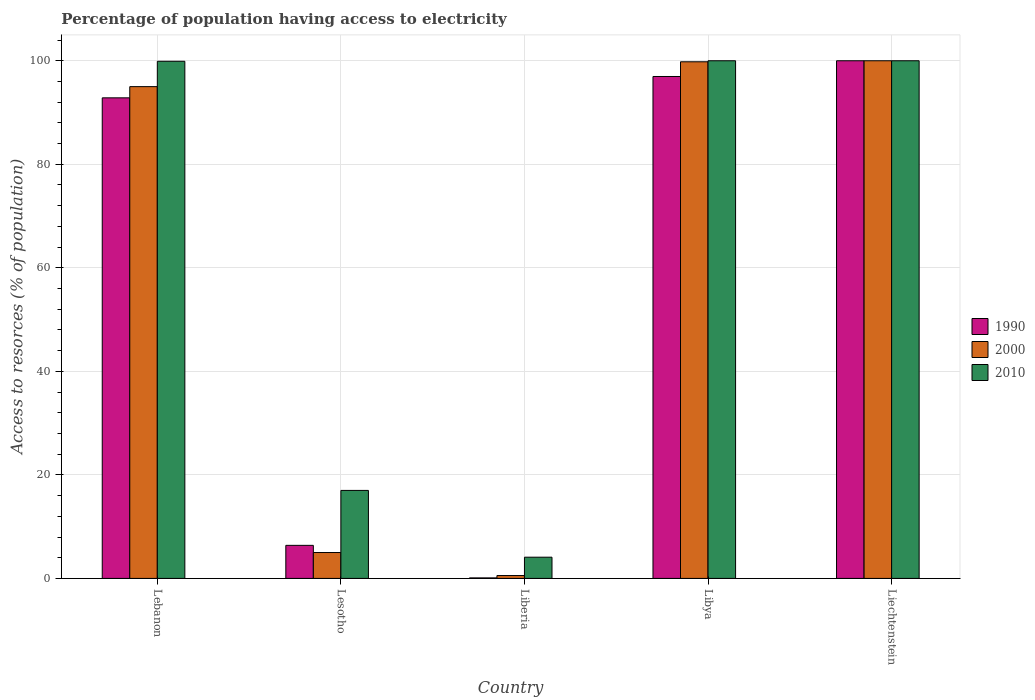How many different coloured bars are there?
Offer a terse response. 3. Are the number of bars per tick equal to the number of legend labels?
Keep it short and to the point. Yes. Are the number of bars on each tick of the X-axis equal?
Offer a terse response. Yes. How many bars are there on the 5th tick from the left?
Your answer should be compact. 3. What is the label of the 1st group of bars from the left?
Keep it short and to the point. Lebanon. In how many cases, is the number of bars for a given country not equal to the number of legend labels?
Ensure brevity in your answer.  0. What is the percentage of population having access to electricity in 2000 in Lesotho?
Ensure brevity in your answer.  5. Across all countries, what is the maximum percentage of population having access to electricity in 2010?
Offer a very short reply. 100. Across all countries, what is the minimum percentage of population having access to electricity in 1990?
Provide a short and direct response. 0.1. In which country was the percentage of population having access to electricity in 2000 maximum?
Offer a terse response. Liechtenstein. In which country was the percentage of population having access to electricity in 1990 minimum?
Provide a succinct answer. Liberia. What is the total percentage of population having access to electricity in 2000 in the graph?
Give a very brief answer. 300.36. What is the difference between the percentage of population having access to electricity in 1990 in Liberia and that in Libya?
Make the answer very short. -96.86. What is the difference between the percentage of population having access to electricity in 1990 in Libya and the percentage of population having access to electricity in 2000 in Lesotho?
Offer a very short reply. 91.96. What is the average percentage of population having access to electricity in 1990 per country?
Your answer should be compact. 59.26. What is the difference between the percentage of population having access to electricity of/in 1990 and percentage of population having access to electricity of/in 2010 in Libya?
Offer a very short reply. -3.04. In how many countries, is the percentage of population having access to electricity in 2010 greater than 88 %?
Your response must be concise. 3. Is the percentage of population having access to electricity in 1990 in Lebanon less than that in Liberia?
Your answer should be compact. No. What is the difference between the highest and the second highest percentage of population having access to electricity in 1990?
Make the answer very short. -3.04. What is the difference between the highest and the lowest percentage of population having access to electricity in 1990?
Keep it short and to the point. 99.9. Is the sum of the percentage of population having access to electricity in 2000 in Lesotho and Libya greater than the maximum percentage of population having access to electricity in 2010 across all countries?
Make the answer very short. Yes. What does the 3rd bar from the right in Lebanon represents?
Ensure brevity in your answer.  1990. Is it the case that in every country, the sum of the percentage of population having access to electricity in 2010 and percentage of population having access to electricity in 2000 is greater than the percentage of population having access to electricity in 1990?
Ensure brevity in your answer.  Yes. How many bars are there?
Provide a succinct answer. 15. Are all the bars in the graph horizontal?
Provide a short and direct response. No. What is the difference between two consecutive major ticks on the Y-axis?
Your response must be concise. 20. Does the graph contain any zero values?
Offer a very short reply. No. How many legend labels are there?
Ensure brevity in your answer.  3. How are the legend labels stacked?
Provide a succinct answer. Vertical. What is the title of the graph?
Offer a very short reply. Percentage of population having access to electricity. What is the label or title of the X-axis?
Keep it short and to the point. Country. What is the label or title of the Y-axis?
Give a very brief answer. Access to resorces (% of population). What is the Access to resorces (% of population) of 1990 in Lebanon?
Ensure brevity in your answer.  92.84. What is the Access to resorces (% of population) of 2010 in Lebanon?
Provide a short and direct response. 99.9. What is the Access to resorces (% of population) in 1990 in Lesotho?
Keep it short and to the point. 6.39. What is the Access to resorces (% of population) of 2000 in Lesotho?
Offer a terse response. 5. What is the Access to resorces (% of population) of 2010 in Lesotho?
Offer a terse response. 17. What is the Access to resorces (% of population) in 1990 in Liberia?
Give a very brief answer. 0.1. What is the Access to resorces (% of population) of 2000 in Liberia?
Provide a short and direct response. 0.56. What is the Access to resorces (% of population) in 1990 in Libya?
Your answer should be compact. 96.96. What is the Access to resorces (% of population) in 2000 in Libya?
Ensure brevity in your answer.  99.8. What is the Access to resorces (% of population) in 2010 in Libya?
Provide a short and direct response. 100. What is the Access to resorces (% of population) of 1990 in Liechtenstein?
Make the answer very short. 100. Across all countries, what is the maximum Access to resorces (% of population) of 2010?
Your answer should be very brief. 100. Across all countries, what is the minimum Access to resorces (% of population) in 1990?
Give a very brief answer. 0.1. Across all countries, what is the minimum Access to resorces (% of population) in 2000?
Provide a succinct answer. 0.56. Across all countries, what is the minimum Access to resorces (% of population) of 2010?
Provide a short and direct response. 4.1. What is the total Access to resorces (% of population) of 1990 in the graph?
Make the answer very short. 296.29. What is the total Access to resorces (% of population) in 2000 in the graph?
Ensure brevity in your answer.  300.36. What is the total Access to resorces (% of population) in 2010 in the graph?
Give a very brief answer. 321. What is the difference between the Access to resorces (% of population) in 1990 in Lebanon and that in Lesotho?
Offer a very short reply. 86.45. What is the difference between the Access to resorces (% of population) of 2010 in Lebanon and that in Lesotho?
Offer a very short reply. 82.9. What is the difference between the Access to resorces (% of population) in 1990 in Lebanon and that in Liberia?
Ensure brevity in your answer.  92.74. What is the difference between the Access to resorces (% of population) in 2000 in Lebanon and that in Liberia?
Your answer should be very brief. 94.44. What is the difference between the Access to resorces (% of population) of 2010 in Lebanon and that in Liberia?
Provide a short and direct response. 95.8. What is the difference between the Access to resorces (% of population) of 1990 in Lebanon and that in Libya?
Make the answer very short. -4.12. What is the difference between the Access to resorces (% of population) of 2000 in Lebanon and that in Libya?
Offer a very short reply. -4.8. What is the difference between the Access to resorces (% of population) in 2010 in Lebanon and that in Libya?
Your response must be concise. -0.1. What is the difference between the Access to resorces (% of population) in 1990 in Lebanon and that in Liechtenstein?
Ensure brevity in your answer.  -7.16. What is the difference between the Access to resorces (% of population) in 1990 in Lesotho and that in Liberia?
Provide a succinct answer. 6.29. What is the difference between the Access to resorces (% of population) of 2000 in Lesotho and that in Liberia?
Give a very brief answer. 4.44. What is the difference between the Access to resorces (% of population) in 2010 in Lesotho and that in Liberia?
Your response must be concise. 12.9. What is the difference between the Access to resorces (% of population) of 1990 in Lesotho and that in Libya?
Your response must be concise. -90.57. What is the difference between the Access to resorces (% of population) in 2000 in Lesotho and that in Libya?
Offer a very short reply. -94.8. What is the difference between the Access to resorces (% of population) in 2010 in Lesotho and that in Libya?
Keep it short and to the point. -83. What is the difference between the Access to resorces (% of population) of 1990 in Lesotho and that in Liechtenstein?
Give a very brief answer. -93.61. What is the difference between the Access to resorces (% of population) of 2000 in Lesotho and that in Liechtenstein?
Ensure brevity in your answer.  -95. What is the difference between the Access to resorces (% of population) in 2010 in Lesotho and that in Liechtenstein?
Make the answer very short. -83. What is the difference between the Access to resorces (% of population) in 1990 in Liberia and that in Libya?
Keep it short and to the point. -96.86. What is the difference between the Access to resorces (% of population) in 2000 in Liberia and that in Libya?
Provide a short and direct response. -99.24. What is the difference between the Access to resorces (% of population) of 2010 in Liberia and that in Libya?
Ensure brevity in your answer.  -95.9. What is the difference between the Access to resorces (% of population) in 1990 in Liberia and that in Liechtenstein?
Your answer should be very brief. -99.9. What is the difference between the Access to resorces (% of population) in 2000 in Liberia and that in Liechtenstein?
Ensure brevity in your answer.  -99.44. What is the difference between the Access to resorces (% of population) of 2010 in Liberia and that in Liechtenstein?
Give a very brief answer. -95.9. What is the difference between the Access to resorces (% of population) of 1990 in Libya and that in Liechtenstein?
Offer a very short reply. -3.04. What is the difference between the Access to resorces (% of population) of 1990 in Lebanon and the Access to resorces (% of population) of 2000 in Lesotho?
Provide a short and direct response. 87.84. What is the difference between the Access to resorces (% of population) in 1990 in Lebanon and the Access to resorces (% of population) in 2010 in Lesotho?
Keep it short and to the point. 75.84. What is the difference between the Access to resorces (% of population) in 1990 in Lebanon and the Access to resorces (% of population) in 2000 in Liberia?
Make the answer very short. 92.28. What is the difference between the Access to resorces (% of population) in 1990 in Lebanon and the Access to resorces (% of population) in 2010 in Liberia?
Offer a very short reply. 88.74. What is the difference between the Access to resorces (% of population) in 2000 in Lebanon and the Access to resorces (% of population) in 2010 in Liberia?
Your answer should be compact. 90.9. What is the difference between the Access to resorces (% of population) in 1990 in Lebanon and the Access to resorces (% of population) in 2000 in Libya?
Make the answer very short. -6.96. What is the difference between the Access to resorces (% of population) in 1990 in Lebanon and the Access to resorces (% of population) in 2010 in Libya?
Give a very brief answer. -7.16. What is the difference between the Access to resorces (% of population) in 2000 in Lebanon and the Access to resorces (% of population) in 2010 in Libya?
Your answer should be compact. -5. What is the difference between the Access to resorces (% of population) of 1990 in Lebanon and the Access to resorces (% of population) of 2000 in Liechtenstein?
Make the answer very short. -7.16. What is the difference between the Access to resorces (% of population) in 1990 in Lebanon and the Access to resorces (% of population) in 2010 in Liechtenstein?
Provide a short and direct response. -7.16. What is the difference between the Access to resorces (% of population) in 1990 in Lesotho and the Access to resorces (% of population) in 2000 in Liberia?
Offer a terse response. 5.83. What is the difference between the Access to resorces (% of population) of 1990 in Lesotho and the Access to resorces (% of population) of 2010 in Liberia?
Your answer should be very brief. 2.29. What is the difference between the Access to resorces (% of population) in 1990 in Lesotho and the Access to resorces (% of population) in 2000 in Libya?
Keep it short and to the point. -93.41. What is the difference between the Access to resorces (% of population) in 1990 in Lesotho and the Access to resorces (% of population) in 2010 in Libya?
Your response must be concise. -93.61. What is the difference between the Access to resorces (% of population) in 2000 in Lesotho and the Access to resorces (% of population) in 2010 in Libya?
Ensure brevity in your answer.  -95. What is the difference between the Access to resorces (% of population) in 1990 in Lesotho and the Access to resorces (% of population) in 2000 in Liechtenstein?
Ensure brevity in your answer.  -93.61. What is the difference between the Access to resorces (% of population) of 1990 in Lesotho and the Access to resorces (% of population) of 2010 in Liechtenstein?
Your answer should be very brief. -93.61. What is the difference between the Access to resorces (% of population) of 2000 in Lesotho and the Access to resorces (% of population) of 2010 in Liechtenstein?
Make the answer very short. -95. What is the difference between the Access to resorces (% of population) in 1990 in Liberia and the Access to resorces (% of population) in 2000 in Libya?
Offer a very short reply. -99.7. What is the difference between the Access to resorces (% of population) in 1990 in Liberia and the Access to resorces (% of population) in 2010 in Libya?
Offer a very short reply. -99.9. What is the difference between the Access to resorces (% of population) of 2000 in Liberia and the Access to resorces (% of population) of 2010 in Libya?
Keep it short and to the point. -99.44. What is the difference between the Access to resorces (% of population) of 1990 in Liberia and the Access to resorces (% of population) of 2000 in Liechtenstein?
Your response must be concise. -99.9. What is the difference between the Access to resorces (% of population) of 1990 in Liberia and the Access to resorces (% of population) of 2010 in Liechtenstein?
Make the answer very short. -99.9. What is the difference between the Access to resorces (% of population) in 2000 in Liberia and the Access to resorces (% of population) in 2010 in Liechtenstein?
Make the answer very short. -99.44. What is the difference between the Access to resorces (% of population) of 1990 in Libya and the Access to resorces (% of population) of 2000 in Liechtenstein?
Provide a succinct answer. -3.04. What is the difference between the Access to resorces (% of population) of 1990 in Libya and the Access to resorces (% of population) of 2010 in Liechtenstein?
Offer a terse response. -3.04. What is the average Access to resorces (% of population) of 1990 per country?
Give a very brief answer. 59.26. What is the average Access to resorces (% of population) of 2000 per country?
Your response must be concise. 60.07. What is the average Access to resorces (% of population) in 2010 per country?
Your response must be concise. 64.2. What is the difference between the Access to resorces (% of population) of 1990 and Access to resorces (% of population) of 2000 in Lebanon?
Provide a short and direct response. -2.16. What is the difference between the Access to resorces (% of population) of 1990 and Access to resorces (% of population) of 2010 in Lebanon?
Ensure brevity in your answer.  -7.06. What is the difference between the Access to resorces (% of population) in 2000 and Access to resorces (% of population) in 2010 in Lebanon?
Offer a terse response. -4.9. What is the difference between the Access to resorces (% of population) in 1990 and Access to resorces (% of population) in 2000 in Lesotho?
Provide a succinct answer. 1.39. What is the difference between the Access to resorces (% of population) of 1990 and Access to resorces (% of population) of 2010 in Lesotho?
Offer a very short reply. -10.61. What is the difference between the Access to resorces (% of population) in 1990 and Access to resorces (% of population) in 2000 in Liberia?
Your response must be concise. -0.46. What is the difference between the Access to resorces (% of population) in 1990 and Access to resorces (% of population) in 2010 in Liberia?
Provide a succinct answer. -4. What is the difference between the Access to resorces (% of population) of 2000 and Access to resorces (% of population) of 2010 in Liberia?
Provide a succinct answer. -3.54. What is the difference between the Access to resorces (% of population) in 1990 and Access to resorces (% of population) in 2000 in Libya?
Keep it short and to the point. -2.84. What is the difference between the Access to resorces (% of population) of 1990 and Access to resorces (% of population) of 2010 in Libya?
Provide a succinct answer. -3.04. What is the difference between the Access to resorces (% of population) in 2000 and Access to resorces (% of population) in 2010 in Libya?
Your answer should be very brief. -0.2. What is the difference between the Access to resorces (% of population) in 1990 and Access to resorces (% of population) in 2000 in Liechtenstein?
Your answer should be very brief. 0. What is the difference between the Access to resorces (% of population) of 1990 and Access to resorces (% of population) of 2010 in Liechtenstein?
Your response must be concise. 0. What is the ratio of the Access to resorces (% of population) of 1990 in Lebanon to that in Lesotho?
Your answer should be very brief. 14.53. What is the ratio of the Access to resorces (% of population) of 2000 in Lebanon to that in Lesotho?
Give a very brief answer. 19. What is the ratio of the Access to resorces (% of population) in 2010 in Lebanon to that in Lesotho?
Offer a very short reply. 5.88. What is the ratio of the Access to resorces (% of population) of 1990 in Lebanon to that in Liberia?
Give a very brief answer. 928.38. What is the ratio of the Access to resorces (% of population) in 2000 in Lebanon to that in Liberia?
Offer a very short reply. 170.91. What is the ratio of the Access to resorces (% of population) of 2010 in Lebanon to that in Liberia?
Make the answer very short. 24.37. What is the ratio of the Access to resorces (% of population) in 1990 in Lebanon to that in Libya?
Provide a short and direct response. 0.96. What is the ratio of the Access to resorces (% of population) of 2000 in Lebanon to that in Libya?
Offer a terse response. 0.95. What is the ratio of the Access to resorces (% of population) of 1990 in Lebanon to that in Liechtenstein?
Make the answer very short. 0.93. What is the ratio of the Access to resorces (% of population) of 1990 in Lesotho to that in Liberia?
Your answer should be compact. 63.88. What is the ratio of the Access to resorces (% of population) in 2000 in Lesotho to that in Liberia?
Your answer should be compact. 9. What is the ratio of the Access to resorces (% of population) in 2010 in Lesotho to that in Liberia?
Your answer should be compact. 4.15. What is the ratio of the Access to resorces (% of population) in 1990 in Lesotho to that in Libya?
Your answer should be very brief. 0.07. What is the ratio of the Access to resorces (% of population) in 2000 in Lesotho to that in Libya?
Provide a short and direct response. 0.05. What is the ratio of the Access to resorces (% of population) in 2010 in Lesotho to that in Libya?
Ensure brevity in your answer.  0.17. What is the ratio of the Access to resorces (% of population) in 1990 in Lesotho to that in Liechtenstein?
Ensure brevity in your answer.  0.06. What is the ratio of the Access to resorces (% of population) of 2010 in Lesotho to that in Liechtenstein?
Your response must be concise. 0.17. What is the ratio of the Access to resorces (% of population) in 2000 in Liberia to that in Libya?
Provide a succinct answer. 0.01. What is the ratio of the Access to resorces (% of population) of 2010 in Liberia to that in Libya?
Offer a very short reply. 0.04. What is the ratio of the Access to resorces (% of population) of 2000 in Liberia to that in Liechtenstein?
Keep it short and to the point. 0.01. What is the ratio of the Access to resorces (% of population) in 2010 in Liberia to that in Liechtenstein?
Make the answer very short. 0.04. What is the ratio of the Access to resorces (% of population) in 1990 in Libya to that in Liechtenstein?
Provide a succinct answer. 0.97. What is the difference between the highest and the second highest Access to resorces (% of population) in 1990?
Give a very brief answer. 3.04. What is the difference between the highest and the second highest Access to resorces (% of population) of 2010?
Ensure brevity in your answer.  0. What is the difference between the highest and the lowest Access to resorces (% of population) of 1990?
Offer a terse response. 99.9. What is the difference between the highest and the lowest Access to resorces (% of population) of 2000?
Your answer should be very brief. 99.44. What is the difference between the highest and the lowest Access to resorces (% of population) in 2010?
Ensure brevity in your answer.  95.9. 